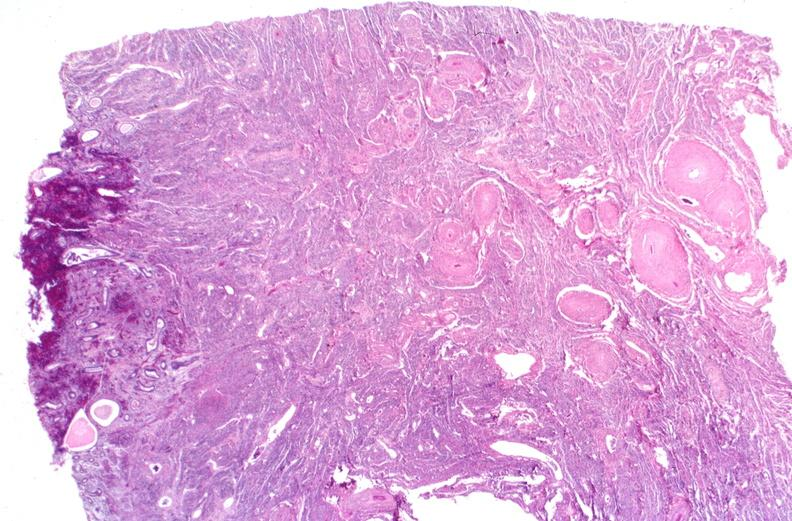where is this?
Answer the question using a single word or phrase. Urinary 